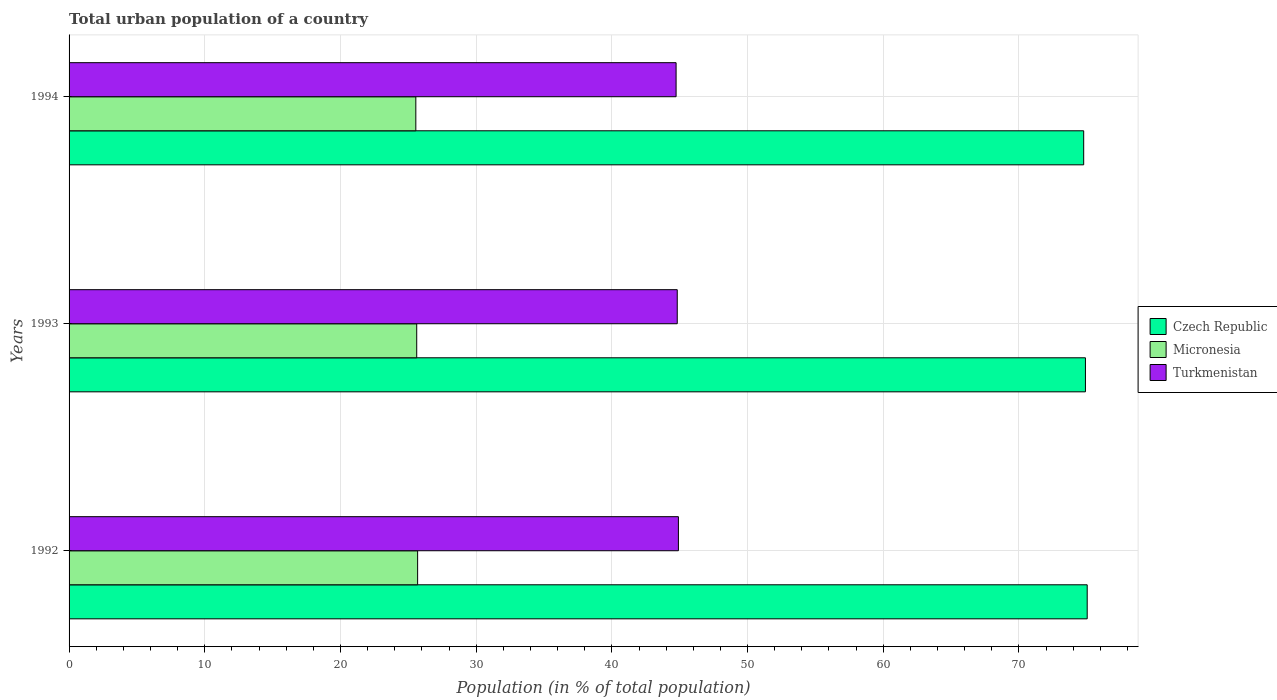Are the number of bars per tick equal to the number of legend labels?
Keep it short and to the point. Yes. Are the number of bars on each tick of the Y-axis equal?
Give a very brief answer. Yes. How many bars are there on the 3rd tick from the top?
Your answer should be compact. 3. What is the label of the 1st group of bars from the top?
Offer a terse response. 1994. What is the urban population in Turkmenistan in 1993?
Give a very brief answer. 44.82. Across all years, what is the maximum urban population in Turkmenistan?
Make the answer very short. 44.9. Across all years, what is the minimum urban population in Czech Republic?
Ensure brevity in your answer.  74.77. In which year was the urban population in Turkmenistan minimum?
Provide a succinct answer. 1994. What is the total urban population in Turkmenistan in the graph?
Make the answer very short. 134.46. What is the difference between the urban population in Turkmenistan in 1993 and that in 1994?
Your answer should be compact. 0.09. What is the difference between the urban population in Turkmenistan in 1992 and the urban population in Micronesia in 1994?
Keep it short and to the point. 19.35. What is the average urban population in Czech Republic per year?
Give a very brief answer. 74.9. In the year 1992, what is the difference between the urban population in Czech Republic and urban population in Micronesia?
Provide a succinct answer. 49.34. What is the ratio of the urban population in Micronesia in 1992 to that in 1994?
Your answer should be very brief. 1.01. What is the difference between the highest and the second highest urban population in Turkmenistan?
Your answer should be compact. 0.09. What is the difference between the highest and the lowest urban population in Turkmenistan?
Offer a terse response. 0.17. In how many years, is the urban population in Turkmenistan greater than the average urban population in Turkmenistan taken over all years?
Provide a short and direct response. 1. What does the 2nd bar from the top in 1993 represents?
Offer a very short reply. Micronesia. What does the 2nd bar from the bottom in 1993 represents?
Offer a very short reply. Micronesia. Is it the case that in every year, the sum of the urban population in Czech Republic and urban population in Turkmenistan is greater than the urban population in Micronesia?
Keep it short and to the point. Yes. How many bars are there?
Give a very brief answer. 9. Are the values on the major ticks of X-axis written in scientific E-notation?
Provide a succinct answer. No. Does the graph contain grids?
Make the answer very short. Yes. How are the legend labels stacked?
Keep it short and to the point. Vertical. What is the title of the graph?
Provide a short and direct response. Total urban population of a country. What is the label or title of the X-axis?
Provide a short and direct response. Population (in % of total population). What is the Population (in % of total population) in Czech Republic in 1992?
Keep it short and to the point. 75.03. What is the Population (in % of total population) in Micronesia in 1992?
Give a very brief answer. 25.69. What is the Population (in % of total population) of Turkmenistan in 1992?
Give a very brief answer. 44.9. What is the Population (in % of total population) of Czech Republic in 1993?
Your answer should be very brief. 74.9. What is the Population (in % of total population) in Micronesia in 1993?
Provide a succinct answer. 25.62. What is the Population (in % of total population) of Turkmenistan in 1993?
Provide a succinct answer. 44.82. What is the Population (in % of total population) in Czech Republic in 1994?
Make the answer very short. 74.77. What is the Population (in % of total population) of Micronesia in 1994?
Provide a short and direct response. 25.55. What is the Population (in % of total population) of Turkmenistan in 1994?
Your answer should be compact. 44.73. Across all years, what is the maximum Population (in % of total population) in Czech Republic?
Provide a succinct answer. 75.03. Across all years, what is the maximum Population (in % of total population) of Micronesia?
Ensure brevity in your answer.  25.69. Across all years, what is the maximum Population (in % of total population) of Turkmenistan?
Your answer should be compact. 44.9. Across all years, what is the minimum Population (in % of total population) in Czech Republic?
Offer a very short reply. 74.77. Across all years, what is the minimum Population (in % of total population) of Micronesia?
Your answer should be compact. 25.55. Across all years, what is the minimum Population (in % of total population) of Turkmenistan?
Ensure brevity in your answer.  44.73. What is the total Population (in % of total population) in Czech Republic in the graph?
Keep it short and to the point. 224.7. What is the total Population (in % of total population) of Micronesia in the graph?
Your answer should be compact. 76.86. What is the total Population (in % of total population) in Turkmenistan in the graph?
Give a very brief answer. 134.46. What is the difference between the Population (in % of total population) of Czech Republic in 1992 and that in 1993?
Your answer should be very brief. 0.13. What is the difference between the Population (in % of total population) in Micronesia in 1992 and that in 1993?
Offer a terse response. 0.07. What is the difference between the Population (in % of total population) of Turkmenistan in 1992 and that in 1993?
Offer a terse response. 0.09. What is the difference between the Population (in % of total population) in Czech Republic in 1992 and that in 1994?
Offer a very short reply. 0.26. What is the difference between the Population (in % of total population) of Micronesia in 1992 and that in 1994?
Give a very brief answer. 0.13. What is the difference between the Population (in % of total population) in Turkmenistan in 1992 and that in 1994?
Ensure brevity in your answer.  0.17. What is the difference between the Population (in % of total population) in Czech Republic in 1993 and that in 1994?
Ensure brevity in your answer.  0.13. What is the difference between the Population (in % of total population) in Micronesia in 1993 and that in 1994?
Provide a succinct answer. 0.07. What is the difference between the Population (in % of total population) in Turkmenistan in 1993 and that in 1994?
Offer a terse response. 0.09. What is the difference between the Population (in % of total population) in Czech Republic in 1992 and the Population (in % of total population) in Micronesia in 1993?
Your answer should be compact. 49.41. What is the difference between the Population (in % of total population) in Czech Republic in 1992 and the Population (in % of total population) in Turkmenistan in 1993?
Keep it short and to the point. 30.21. What is the difference between the Population (in % of total population) of Micronesia in 1992 and the Population (in % of total population) of Turkmenistan in 1993?
Offer a terse response. -19.13. What is the difference between the Population (in % of total population) of Czech Republic in 1992 and the Population (in % of total population) of Micronesia in 1994?
Provide a short and direct response. 49.48. What is the difference between the Population (in % of total population) in Czech Republic in 1992 and the Population (in % of total population) in Turkmenistan in 1994?
Your answer should be compact. 30.3. What is the difference between the Population (in % of total population) in Micronesia in 1992 and the Population (in % of total population) in Turkmenistan in 1994?
Ensure brevity in your answer.  -19.05. What is the difference between the Population (in % of total population) in Czech Republic in 1993 and the Population (in % of total population) in Micronesia in 1994?
Offer a very short reply. 49.35. What is the difference between the Population (in % of total population) of Czech Republic in 1993 and the Population (in % of total population) of Turkmenistan in 1994?
Give a very brief answer. 30.17. What is the difference between the Population (in % of total population) in Micronesia in 1993 and the Population (in % of total population) in Turkmenistan in 1994?
Your answer should be very brief. -19.11. What is the average Population (in % of total population) of Czech Republic per year?
Offer a terse response. 74.9. What is the average Population (in % of total population) in Micronesia per year?
Offer a very short reply. 25.62. What is the average Population (in % of total population) of Turkmenistan per year?
Provide a succinct answer. 44.82. In the year 1992, what is the difference between the Population (in % of total population) in Czech Republic and Population (in % of total population) in Micronesia?
Your response must be concise. 49.34. In the year 1992, what is the difference between the Population (in % of total population) of Czech Republic and Population (in % of total population) of Turkmenistan?
Offer a terse response. 30.13. In the year 1992, what is the difference between the Population (in % of total population) in Micronesia and Population (in % of total population) in Turkmenistan?
Offer a terse response. -19.22. In the year 1993, what is the difference between the Population (in % of total population) of Czech Republic and Population (in % of total population) of Micronesia?
Offer a very short reply. 49.28. In the year 1993, what is the difference between the Population (in % of total population) in Czech Republic and Population (in % of total population) in Turkmenistan?
Ensure brevity in your answer.  30.08. In the year 1993, what is the difference between the Population (in % of total population) in Micronesia and Population (in % of total population) in Turkmenistan?
Your response must be concise. -19.2. In the year 1994, what is the difference between the Population (in % of total population) in Czech Republic and Population (in % of total population) in Micronesia?
Keep it short and to the point. 49.22. In the year 1994, what is the difference between the Population (in % of total population) in Czech Republic and Population (in % of total population) in Turkmenistan?
Your answer should be compact. 30.04. In the year 1994, what is the difference between the Population (in % of total population) of Micronesia and Population (in % of total population) of Turkmenistan?
Provide a short and direct response. -19.18. What is the ratio of the Population (in % of total population) in Micronesia in 1992 to that in 1993?
Your answer should be very brief. 1. What is the ratio of the Population (in % of total population) of Turkmenistan in 1992 to that in 1993?
Provide a short and direct response. 1. What is the ratio of the Population (in % of total population) of Micronesia in 1992 to that in 1994?
Your answer should be very brief. 1.01. What is the ratio of the Population (in % of total population) in Czech Republic in 1993 to that in 1994?
Make the answer very short. 1. What is the difference between the highest and the second highest Population (in % of total population) in Czech Republic?
Your answer should be very brief. 0.13. What is the difference between the highest and the second highest Population (in % of total population) in Micronesia?
Make the answer very short. 0.07. What is the difference between the highest and the second highest Population (in % of total population) of Turkmenistan?
Your answer should be compact. 0.09. What is the difference between the highest and the lowest Population (in % of total population) in Czech Republic?
Ensure brevity in your answer.  0.26. What is the difference between the highest and the lowest Population (in % of total population) in Micronesia?
Keep it short and to the point. 0.13. What is the difference between the highest and the lowest Population (in % of total population) in Turkmenistan?
Offer a very short reply. 0.17. 